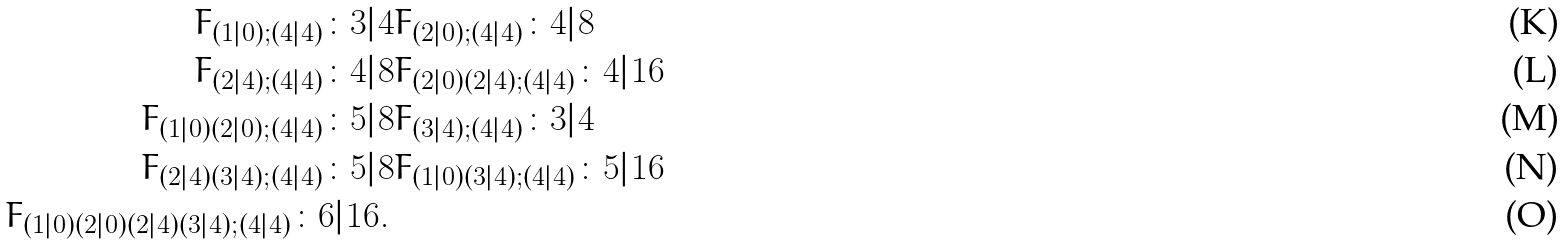<formula> <loc_0><loc_0><loc_500><loc_500>F _ { ( 1 | 0 ) ; ( 4 | 4 ) } \colon 3 | 4 & F _ { ( 2 | 0 ) ; ( 4 | 4 ) } \colon 4 | 8 \\ F _ { ( 2 | 4 ) ; ( 4 | 4 ) } \colon 4 | 8 & F _ { ( 2 | 0 ) ( 2 | 4 ) ; ( 4 | 4 ) } \colon 4 | 1 6 \\ F _ { ( 1 | 0 ) ( 2 | 0 ) ; ( 4 | 4 ) } \colon 5 | 8 & F _ { ( 3 | 4 ) ; ( 4 | 4 ) } \colon 3 | 4 \\ F _ { ( 2 | 4 ) ( 3 | 4 ) ; ( 4 | 4 ) } \colon 5 | 8 & F _ { ( 1 | 0 ) ( 3 | 4 ) ; ( 4 | 4 ) } \colon 5 | 1 6 \\ F _ { ( 1 | 0 ) ( 2 | 0 ) ( 2 | 4 ) ( 3 | 4 ) ; ( 4 | 4 ) } \colon 6 | 1 6 . \, &</formula> 